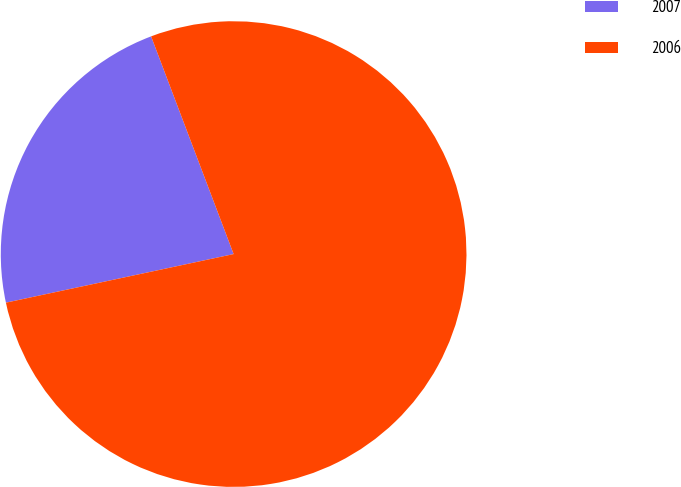<chart> <loc_0><loc_0><loc_500><loc_500><pie_chart><fcel>2007<fcel>2006<nl><fcel>22.58%<fcel>77.42%<nl></chart> 